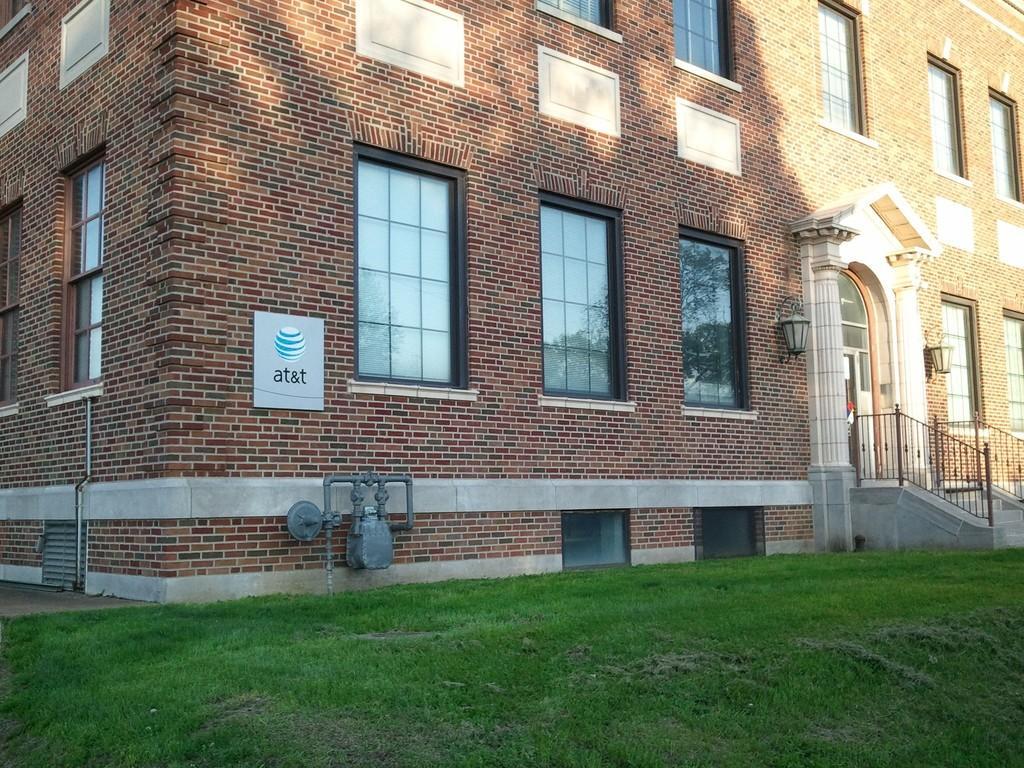In one or two sentences, can you explain what this image depicts? In this image I can see a building with so many windows, in-front of that there is a grass ground. 